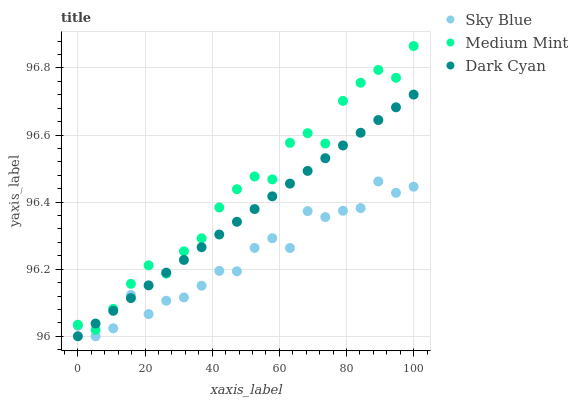Does Sky Blue have the minimum area under the curve?
Answer yes or no. Yes. Does Medium Mint have the maximum area under the curve?
Answer yes or no. Yes. Does Dark Cyan have the minimum area under the curve?
Answer yes or no. No. Does Dark Cyan have the maximum area under the curve?
Answer yes or no. No. Is Dark Cyan the smoothest?
Answer yes or no. Yes. Is Sky Blue the roughest?
Answer yes or no. Yes. Is Sky Blue the smoothest?
Answer yes or no. No. Is Dark Cyan the roughest?
Answer yes or no. No. Does Sky Blue have the lowest value?
Answer yes or no. Yes. Does Medium Mint have the highest value?
Answer yes or no. Yes. Does Dark Cyan have the highest value?
Answer yes or no. No. Is Sky Blue less than Medium Mint?
Answer yes or no. Yes. Is Medium Mint greater than Sky Blue?
Answer yes or no. Yes. Does Medium Mint intersect Dark Cyan?
Answer yes or no. Yes. Is Medium Mint less than Dark Cyan?
Answer yes or no. No. Is Medium Mint greater than Dark Cyan?
Answer yes or no. No. Does Sky Blue intersect Medium Mint?
Answer yes or no. No. 